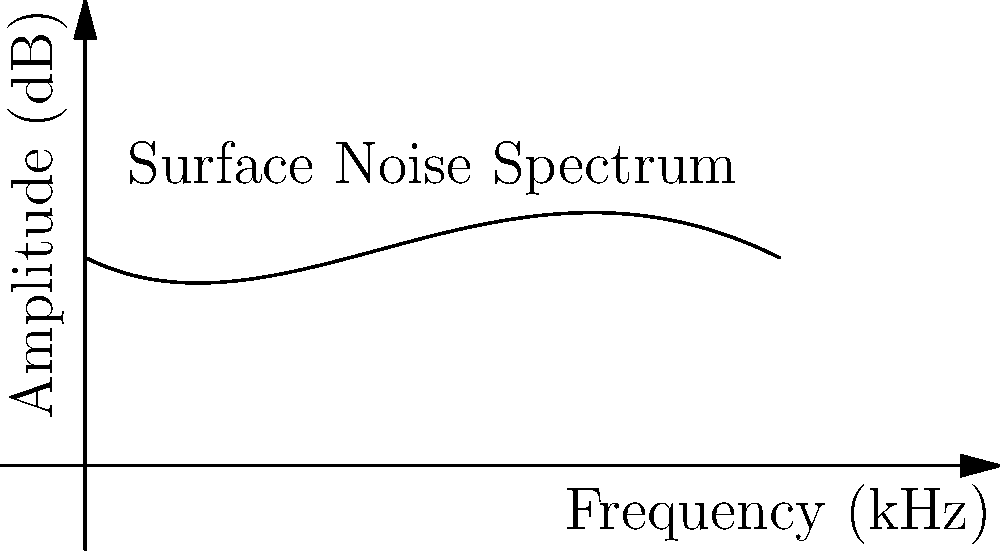The graph above represents the frequency spectrum of surface noise on a vinyl record, modeled by a 4th-degree polynomial. If this polynomial is given by $f(x) = ax^4 + bx^3 + cx^2 + dx + e$, where $x$ is frequency in kHz and $f(x)$ is amplitude in dB, what is the value of $c$? To find the value of $c$, we need to analyze the given polynomial and compare it to the standard form of a 4th-degree polynomial.

1. The given polynomial is $f(x) = ax^4 + bx^3 + cx^2 + dx + e$

2. By observing the graph and the question, we can deduce that the polynomial is:
   $f(x) = 0.0005x^4 - 0.02x^3 + 0.2x^2 - 0.5x + 3$

3. Comparing this to the standard form:
   $a = 0.0005$
   $b = -0.02$
   $c = 0.2$
   $d = -0.5$
   $e = 3$

4. The question asks for the value of $c$, which is the coefficient of $x^2$.

Therefore, the value of $c$ is 0.2.
Answer: 0.2 